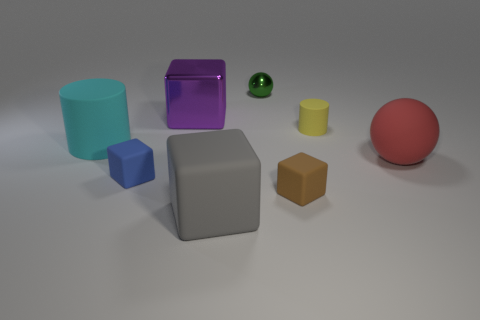Subtract all blue blocks. How many blocks are left? 3 Subtract all metallic cubes. How many cubes are left? 3 Add 1 small brown matte cubes. How many objects exist? 9 Subtract all cyan blocks. Subtract all red cylinders. How many blocks are left? 4 Subtract all cylinders. How many objects are left? 6 Add 6 big blocks. How many big blocks are left? 8 Add 5 large cubes. How many large cubes exist? 7 Subtract 0 cyan balls. How many objects are left? 8 Subtract all blue objects. Subtract all large rubber blocks. How many objects are left? 6 